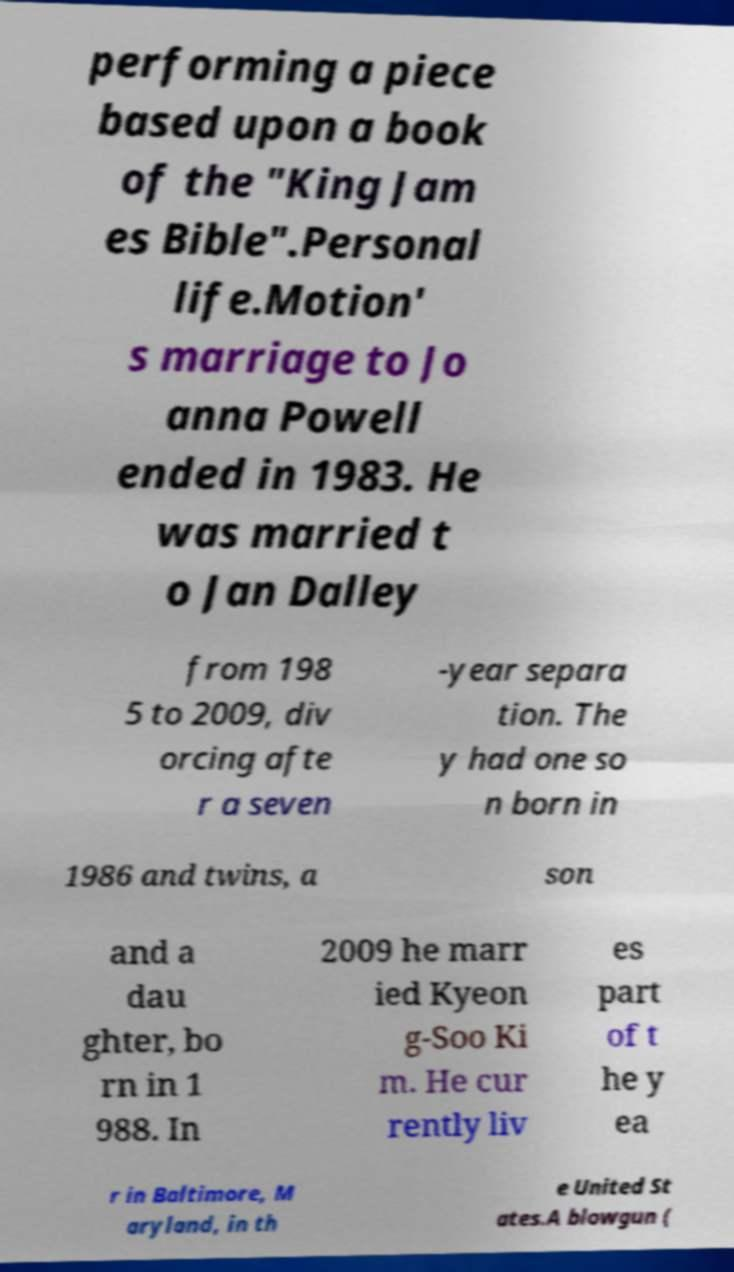Can you accurately transcribe the text from the provided image for me? performing a piece based upon a book of the "King Jam es Bible".Personal life.Motion' s marriage to Jo anna Powell ended in 1983. He was married t o Jan Dalley from 198 5 to 2009, div orcing afte r a seven -year separa tion. The y had one so n born in 1986 and twins, a son and a dau ghter, bo rn in 1 988. In 2009 he marr ied Kyeon g-Soo Ki m. He cur rently liv es part of t he y ea r in Baltimore, M aryland, in th e United St ates.A blowgun ( 